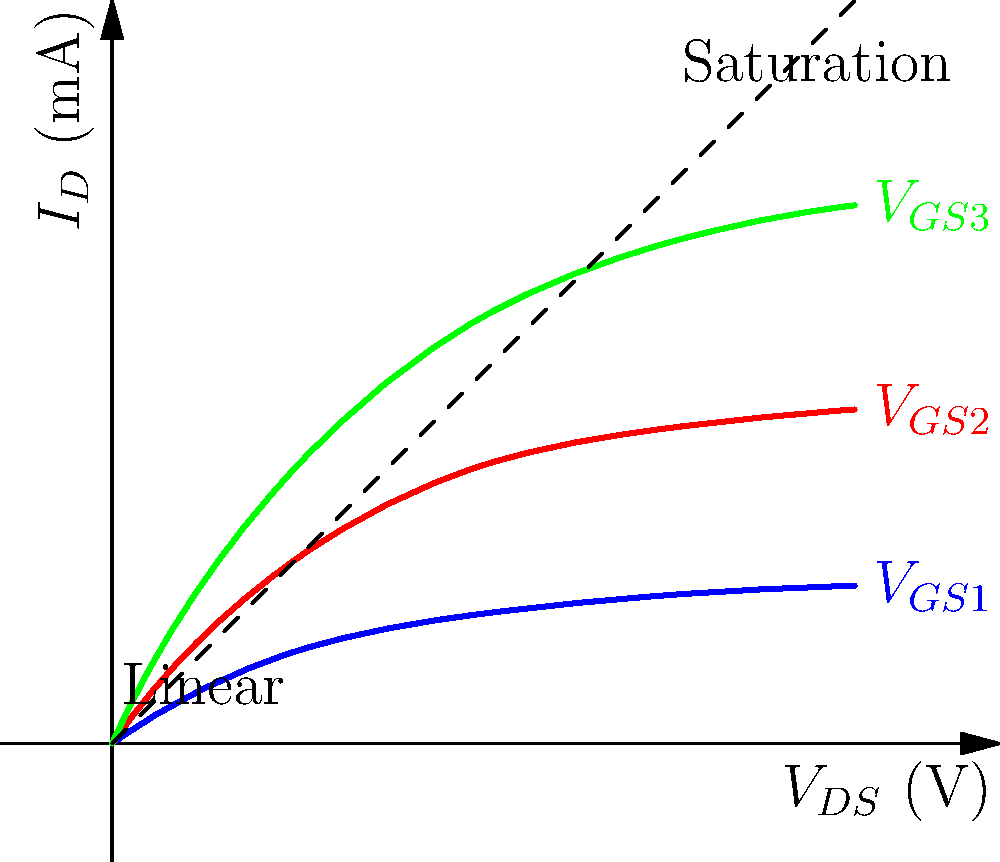In the context of asymmetric warfare, consider a scenario where a non-state actor is developing low-cost, miniaturized electronic warfare devices. Given the transistor characteristic curves shown, which region of operation would be most suitable for designing a low-power, efficient amplifier for these devices, and why? To answer this question, we need to consider the characteristics of transistor operation in different regions and relate them to the requirements of low-power, efficient amplifiers in the context of asymmetric warfare:

1. Linear (Triode) Region:
   - Located in the leftmost part of the curves where they are rising steeply
   - Transistor behaves like a voltage-controlled resistor
   - High power consumption, low efficiency

2. Saturation Region:
   - Located where the curves flatten out and become nearly horizontal
   - Transistor behaves like a current source controlled by gate voltage
   - Lower power consumption, higher efficiency

3. Cut-off Region (not shown in the graph):
   - Occurs when gate voltage is below the threshold
   - Transistor is effectively off, minimal current flow

For designing low-power, efficient amplifiers:

1. Power efficiency is crucial for portable, battery-operated devices used in asymmetric warfare
2. Saturation region offers the best trade-off between power consumption and amplification
3. In saturation, small changes in gate voltage result in significant changes in drain current, providing good amplification
4. Operating in saturation minimizes power dissipation compared to the linear region

Therefore, the saturation region would be most suitable for designing low-power, efficient amplifiers for miniaturized electronic warfare devices used in asymmetric warfare scenarios.
Answer: Saturation region 